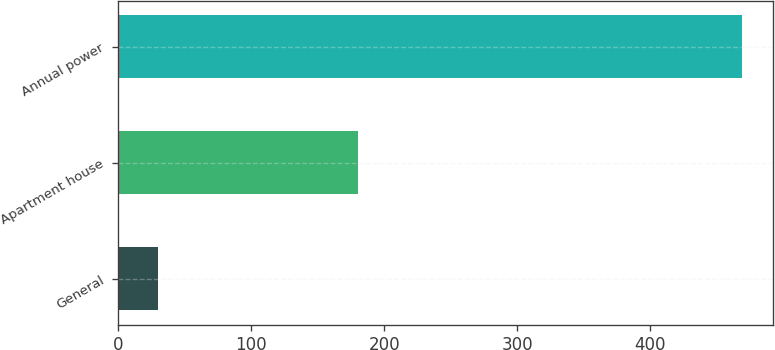<chart> <loc_0><loc_0><loc_500><loc_500><bar_chart><fcel>General<fcel>Apartment house<fcel>Annual power<nl><fcel>30<fcel>180<fcel>469<nl></chart> 